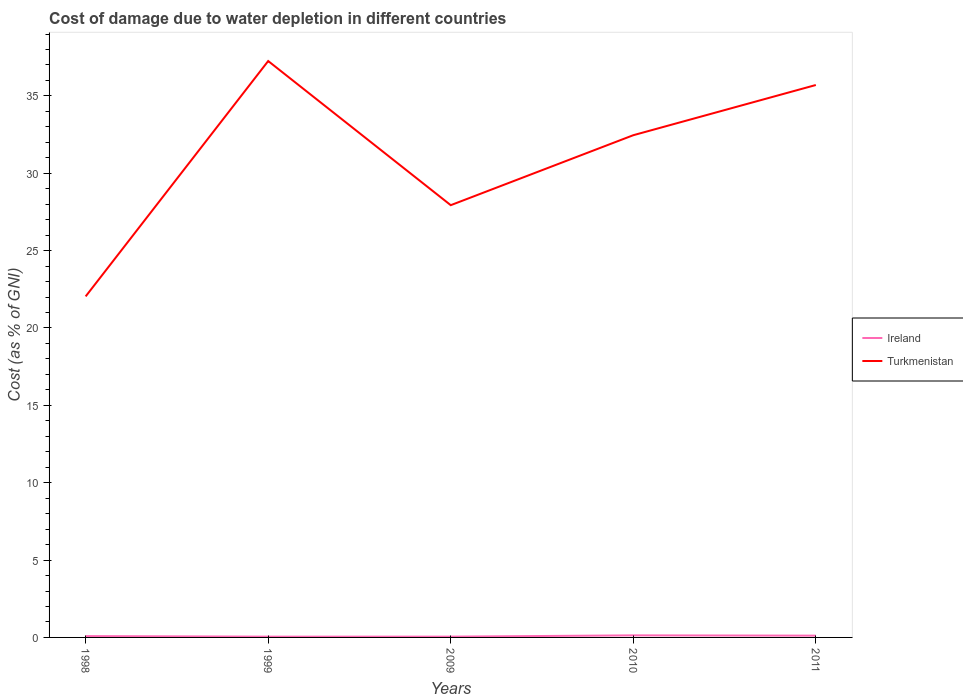How many different coloured lines are there?
Your answer should be compact. 2. Across all years, what is the maximum cost of damage caused due to water depletion in Ireland?
Keep it short and to the point. 0.05. What is the total cost of damage caused due to water depletion in Turkmenistan in the graph?
Offer a very short reply. 4.79. What is the difference between the highest and the second highest cost of damage caused due to water depletion in Ireland?
Ensure brevity in your answer.  0.08. What is the difference between the highest and the lowest cost of damage caused due to water depletion in Turkmenistan?
Give a very brief answer. 3. How many lines are there?
Keep it short and to the point. 2. How many years are there in the graph?
Give a very brief answer. 5. What is the difference between two consecutive major ticks on the Y-axis?
Make the answer very short. 5. Are the values on the major ticks of Y-axis written in scientific E-notation?
Your answer should be very brief. No. Does the graph contain grids?
Keep it short and to the point. No. Where does the legend appear in the graph?
Ensure brevity in your answer.  Center right. How many legend labels are there?
Offer a very short reply. 2. What is the title of the graph?
Offer a very short reply. Cost of damage due to water depletion in different countries. What is the label or title of the Y-axis?
Offer a very short reply. Cost (as % of GNI). What is the Cost (as % of GNI) of Ireland in 1998?
Provide a short and direct response. 0.09. What is the Cost (as % of GNI) in Turkmenistan in 1998?
Offer a very short reply. 22.04. What is the Cost (as % of GNI) in Ireland in 1999?
Keep it short and to the point. 0.05. What is the Cost (as % of GNI) in Turkmenistan in 1999?
Offer a terse response. 37.25. What is the Cost (as % of GNI) of Ireland in 2009?
Offer a terse response. 0.05. What is the Cost (as % of GNI) of Turkmenistan in 2009?
Your answer should be compact. 27.94. What is the Cost (as % of GNI) of Ireland in 2010?
Provide a succinct answer. 0.13. What is the Cost (as % of GNI) of Turkmenistan in 2010?
Ensure brevity in your answer.  32.46. What is the Cost (as % of GNI) in Ireland in 2011?
Give a very brief answer. 0.12. What is the Cost (as % of GNI) in Turkmenistan in 2011?
Provide a succinct answer. 35.7. Across all years, what is the maximum Cost (as % of GNI) in Ireland?
Keep it short and to the point. 0.13. Across all years, what is the maximum Cost (as % of GNI) of Turkmenistan?
Keep it short and to the point. 37.25. Across all years, what is the minimum Cost (as % of GNI) in Ireland?
Offer a very short reply. 0.05. Across all years, what is the minimum Cost (as % of GNI) of Turkmenistan?
Make the answer very short. 22.04. What is the total Cost (as % of GNI) of Ireland in the graph?
Keep it short and to the point. 0.44. What is the total Cost (as % of GNI) of Turkmenistan in the graph?
Your answer should be compact. 155.4. What is the difference between the Cost (as % of GNI) in Ireland in 1998 and that in 1999?
Offer a terse response. 0.04. What is the difference between the Cost (as % of GNI) of Turkmenistan in 1998 and that in 1999?
Offer a terse response. -15.21. What is the difference between the Cost (as % of GNI) in Ireland in 1998 and that in 2009?
Your response must be concise. 0.04. What is the difference between the Cost (as % of GNI) in Turkmenistan in 1998 and that in 2009?
Give a very brief answer. -5.9. What is the difference between the Cost (as % of GNI) in Ireland in 1998 and that in 2010?
Offer a very short reply. -0.05. What is the difference between the Cost (as % of GNI) of Turkmenistan in 1998 and that in 2010?
Give a very brief answer. -10.42. What is the difference between the Cost (as % of GNI) in Ireland in 1998 and that in 2011?
Your answer should be compact. -0.03. What is the difference between the Cost (as % of GNI) in Turkmenistan in 1998 and that in 2011?
Ensure brevity in your answer.  -13.66. What is the difference between the Cost (as % of GNI) in Ireland in 1999 and that in 2009?
Your response must be concise. -0. What is the difference between the Cost (as % of GNI) in Turkmenistan in 1999 and that in 2009?
Provide a short and direct response. 9.32. What is the difference between the Cost (as % of GNI) in Ireland in 1999 and that in 2010?
Provide a succinct answer. -0.08. What is the difference between the Cost (as % of GNI) in Turkmenistan in 1999 and that in 2010?
Provide a succinct answer. 4.79. What is the difference between the Cost (as % of GNI) of Ireland in 1999 and that in 2011?
Give a very brief answer. -0.07. What is the difference between the Cost (as % of GNI) of Turkmenistan in 1999 and that in 2011?
Your answer should be compact. 1.55. What is the difference between the Cost (as % of GNI) of Ireland in 2009 and that in 2010?
Provide a short and direct response. -0.08. What is the difference between the Cost (as % of GNI) in Turkmenistan in 2009 and that in 2010?
Offer a very short reply. -4.52. What is the difference between the Cost (as % of GNI) of Ireland in 2009 and that in 2011?
Offer a very short reply. -0.06. What is the difference between the Cost (as % of GNI) in Turkmenistan in 2009 and that in 2011?
Your answer should be very brief. -7.77. What is the difference between the Cost (as % of GNI) in Ireland in 2010 and that in 2011?
Offer a very short reply. 0.02. What is the difference between the Cost (as % of GNI) in Turkmenistan in 2010 and that in 2011?
Your response must be concise. -3.25. What is the difference between the Cost (as % of GNI) in Ireland in 1998 and the Cost (as % of GNI) in Turkmenistan in 1999?
Your answer should be compact. -37.17. What is the difference between the Cost (as % of GNI) in Ireland in 1998 and the Cost (as % of GNI) in Turkmenistan in 2009?
Your response must be concise. -27.85. What is the difference between the Cost (as % of GNI) of Ireland in 1998 and the Cost (as % of GNI) of Turkmenistan in 2010?
Provide a succinct answer. -32.37. What is the difference between the Cost (as % of GNI) in Ireland in 1998 and the Cost (as % of GNI) in Turkmenistan in 2011?
Offer a very short reply. -35.62. What is the difference between the Cost (as % of GNI) in Ireland in 1999 and the Cost (as % of GNI) in Turkmenistan in 2009?
Give a very brief answer. -27.89. What is the difference between the Cost (as % of GNI) in Ireland in 1999 and the Cost (as % of GNI) in Turkmenistan in 2010?
Offer a terse response. -32.41. What is the difference between the Cost (as % of GNI) in Ireland in 1999 and the Cost (as % of GNI) in Turkmenistan in 2011?
Your answer should be compact. -35.65. What is the difference between the Cost (as % of GNI) of Ireland in 2009 and the Cost (as % of GNI) of Turkmenistan in 2010?
Make the answer very short. -32.41. What is the difference between the Cost (as % of GNI) of Ireland in 2009 and the Cost (as % of GNI) of Turkmenistan in 2011?
Provide a succinct answer. -35.65. What is the difference between the Cost (as % of GNI) of Ireland in 2010 and the Cost (as % of GNI) of Turkmenistan in 2011?
Make the answer very short. -35.57. What is the average Cost (as % of GNI) of Ireland per year?
Your answer should be compact. 0.09. What is the average Cost (as % of GNI) in Turkmenistan per year?
Offer a terse response. 31.08. In the year 1998, what is the difference between the Cost (as % of GNI) of Ireland and Cost (as % of GNI) of Turkmenistan?
Keep it short and to the point. -21.96. In the year 1999, what is the difference between the Cost (as % of GNI) of Ireland and Cost (as % of GNI) of Turkmenistan?
Your answer should be very brief. -37.2. In the year 2009, what is the difference between the Cost (as % of GNI) of Ireland and Cost (as % of GNI) of Turkmenistan?
Provide a short and direct response. -27.89. In the year 2010, what is the difference between the Cost (as % of GNI) in Ireland and Cost (as % of GNI) in Turkmenistan?
Offer a terse response. -32.33. In the year 2011, what is the difference between the Cost (as % of GNI) of Ireland and Cost (as % of GNI) of Turkmenistan?
Your response must be concise. -35.59. What is the ratio of the Cost (as % of GNI) in Ireland in 1998 to that in 1999?
Offer a very short reply. 1.72. What is the ratio of the Cost (as % of GNI) of Turkmenistan in 1998 to that in 1999?
Provide a short and direct response. 0.59. What is the ratio of the Cost (as % of GNI) of Ireland in 1998 to that in 2009?
Provide a short and direct response. 1.71. What is the ratio of the Cost (as % of GNI) of Turkmenistan in 1998 to that in 2009?
Give a very brief answer. 0.79. What is the ratio of the Cost (as % of GNI) of Ireland in 1998 to that in 2010?
Provide a succinct answer. 0.64. What is the ratio of the Cost (as % of GNI) in Turkmenistan in 1998 to that in 2010?
Provide a succinct answer. 0.68. What is the ratio of the Cost (as % of GNI) in Ireland in 1998 to that in 2011?
Offer a very short reply. 0.75. What is the ratio of the Cost (as % of GNI) in Turkmenistan in 1998 to that in 2011?
Your response must be concise. 0.62. What is the ratio of the Cost (as % of GNI) of Ireland in 1999 to that in 2009?
Ensure brevity in your answer.  1. What is the ratio of the Cost (as % of GNI) in Turkmenistan in 1999 to that in 2009?
Offer a terse response. 1.33. What is the ratio of the Cost (as % of GNI) in Ireland in 1999 to that in 2010?
Provide a short and direct response. 0.37. What is the ratio of the Cost (as % of GNI) of Turkmenistan in 1999 to that in 2010?
Provide a short and direct response. 1.15. What is the ratio of the Cost (as % of GNI) in Ireland in 1999 to that in 2011?
Your response must be concise. 0.44. What is the ratio of the Cost (as % of GNI) in Turkmenistan in 1999 to that in 2011?
Provide a short and direct response. 1.04. What is the ratio of the Cost (as % of GNI) of Ireland in 2009 to that in 2010?
Provide a short and direct response. 0.38. What is the ratio of the Cost (as % of GNI) of Turkmenistan in 2009 to that in 2010?
Give a very brief answer. 0.86. What is the ratio of the Cost (as % of GNI) in Ireland in 2009 to that in 2011?
Ensure brevity in your answer.  0.44. What is the ratio of the Cost (as % of GNI) in Turkmenistan in 2009 to that in 2011?
Make the answer very short. 0.78. What is the ratio of the Cost (as % of GNI) of Ireland in 2010 to that in 2011?
Keep it short and to the point. 1.16. What is the ratio of the Cost (as % of GNI) in Turkmenistan in 2010 to that in 2011?
Keep it short and to the point. 0.91. What is the difference between the highest and the second highest Cost (as % of GNI) in Ireland?
Your response must be concise. 0.02. What is the difference between the highest and the second highest Cost (as % of GNI) in Turkmenistan?
Provide a short and direct response. 1.55. What is the difference between the highest and the lowest Cost (as % of GNI) in Ireland?
Give a very brief answer. 0.08. What is the difference between the highest and the lowest Cost (as % of GNI) in Turkmenistan?
Ensure brevity in your answer.  15.21. 